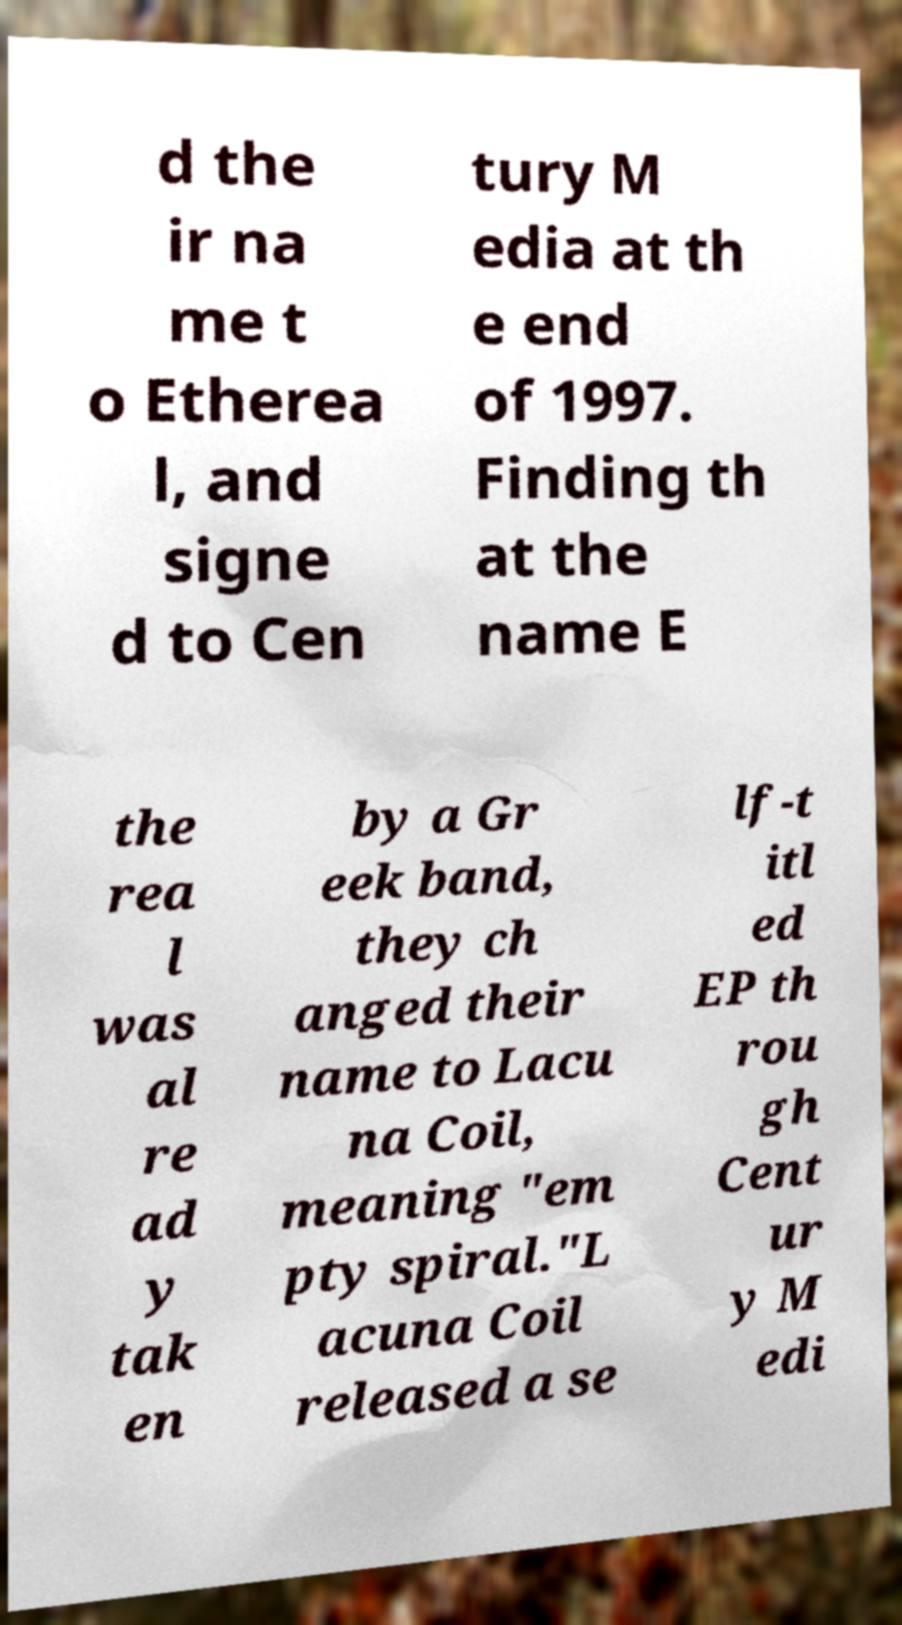I need the written content from this picture converted into text. Can you do that? d the ir na me t o Etherea l, and signe d to Cen tury M edia at th e end of 1997. Finding th at the name E the rea l was al re ad y tak en by a Gr eek band, they ch anged their name to Lacu na Coil, meaning "em pty spiral."L acuna Coil released a se lf-t itl ed EP th rou gh Cent ur y M edi 